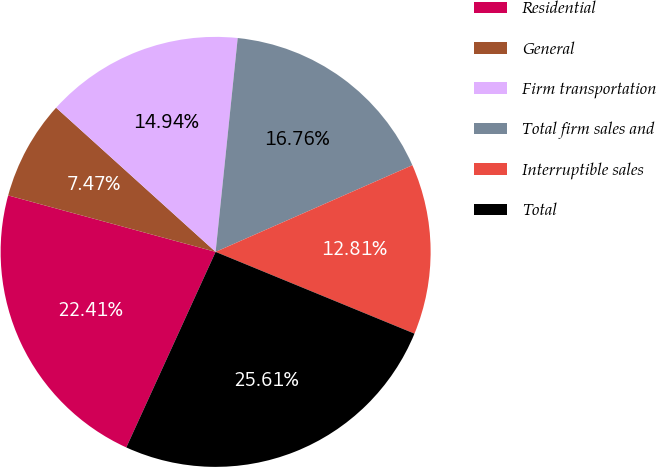Convert chart. <chart><loc_0><loc_0><loc_500><loc_500><pie_chart><fcel>Residential<fcel>General<fcel>Firm transportation<fcel>Total firm sales and<fcel>Interruptible sales<fcel>Total<nl><fcel>22.41%<fcel>7.47%<fcel>14.94%<fcel>16.76%<fcel>12.81%<fcel>25.61%<nl></chart> 